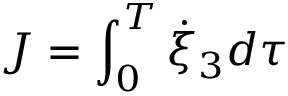Convert formula to latex. <formula><loc_0><loc_0><loc_500><loc_500>J = \int _ { 0 } ^ { T } \dot { \xi } _ { 3 } d \tau</formula> 